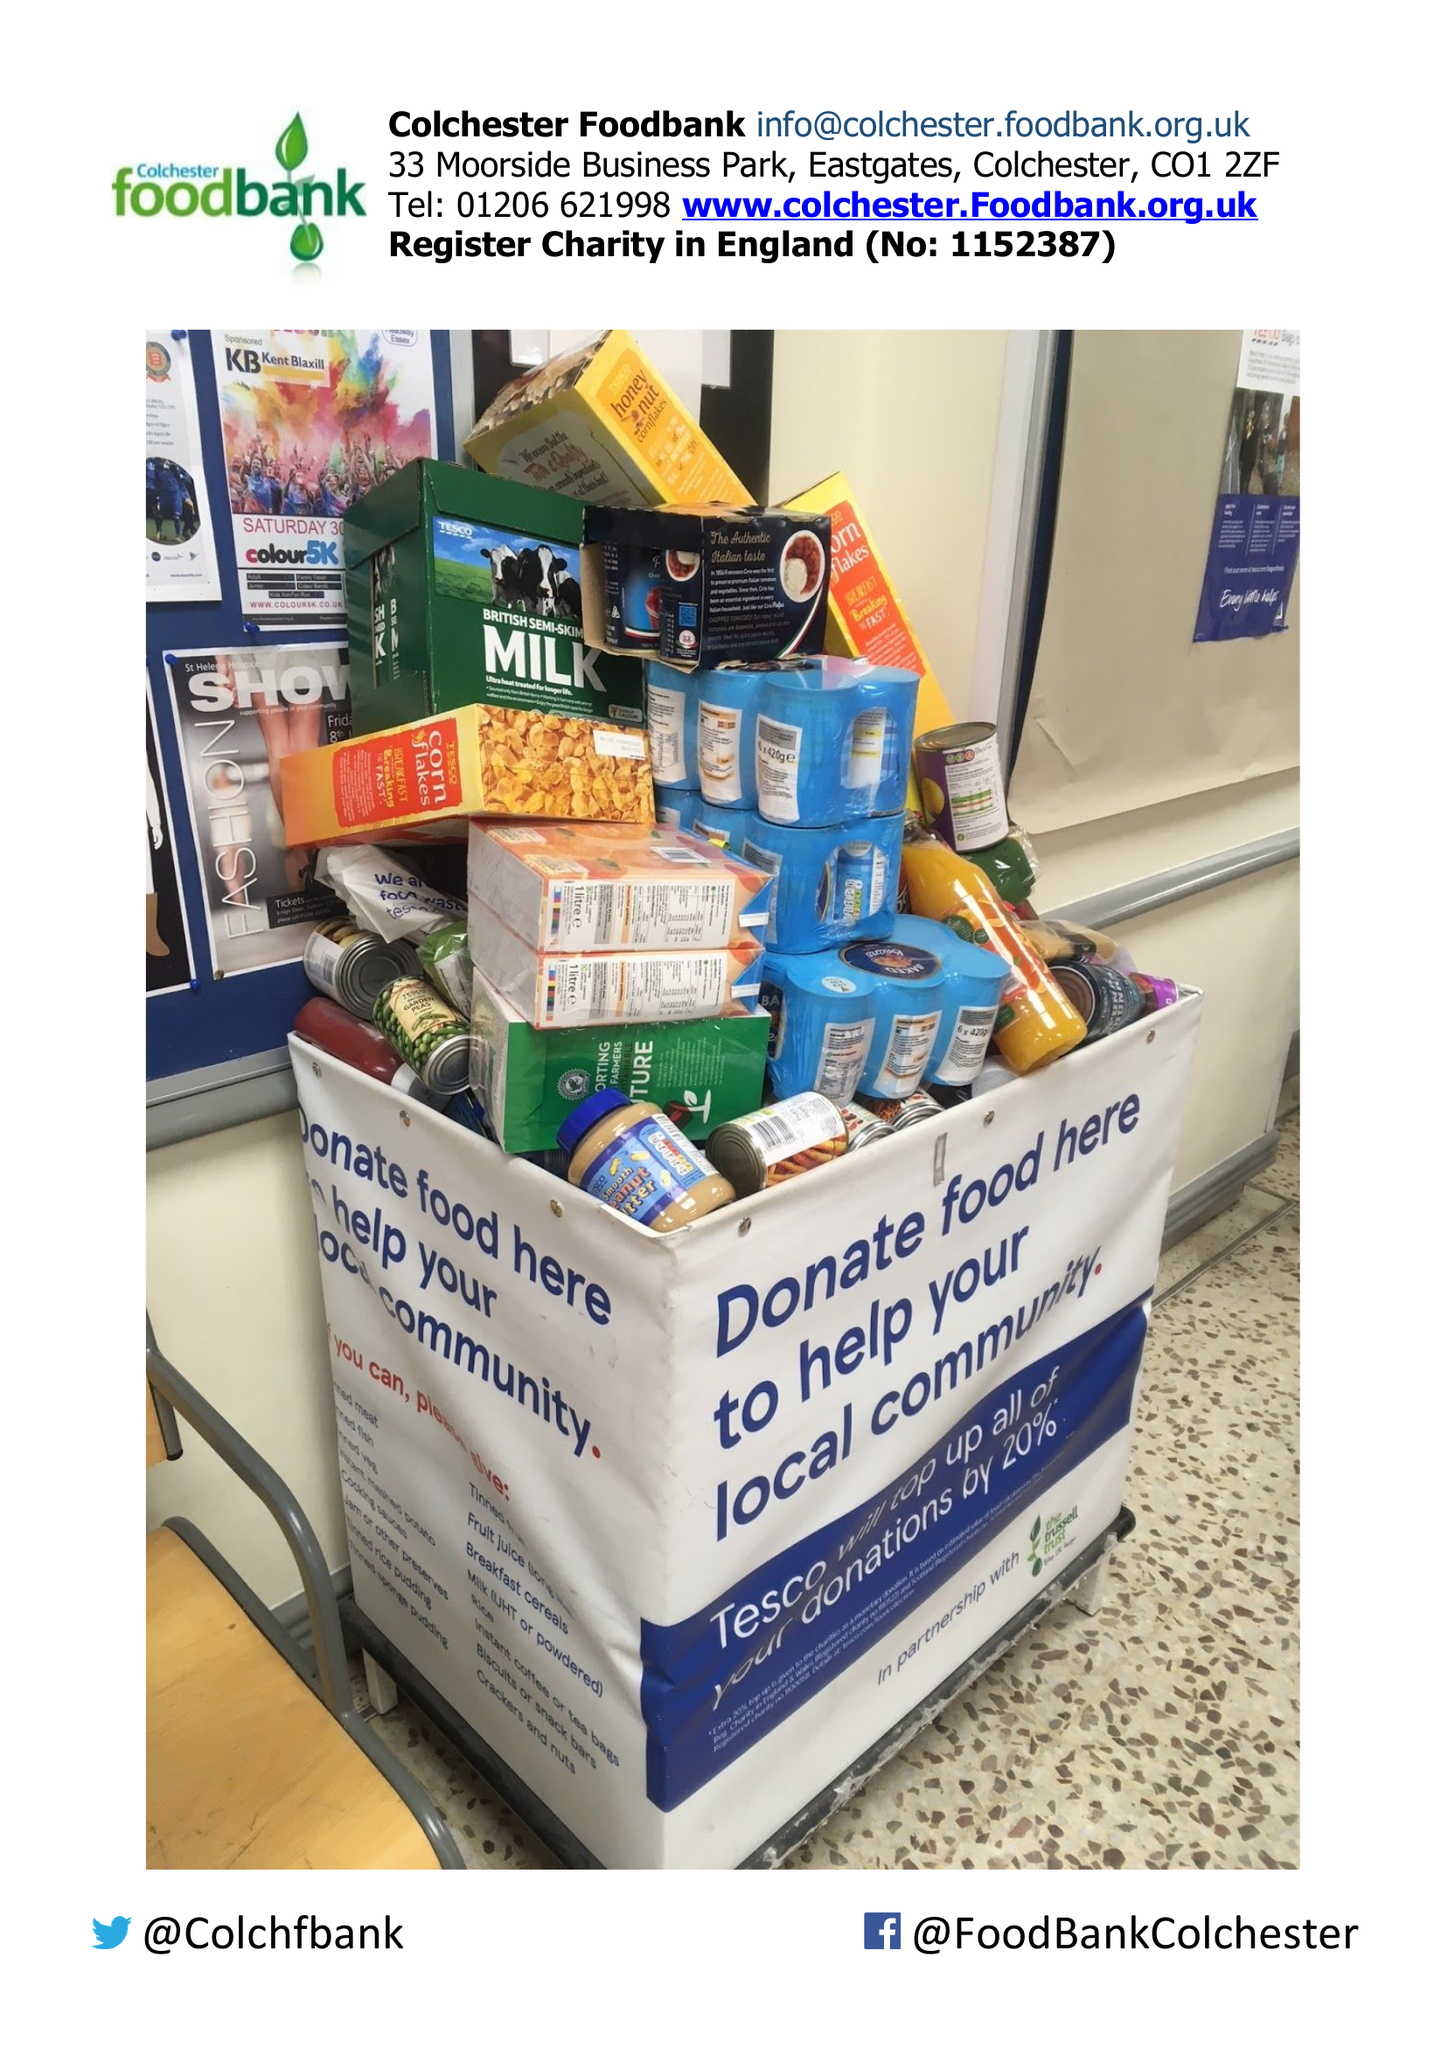What is the value for the address__post_town?
Answer the question using a single word or phrase. COLCHESTER 